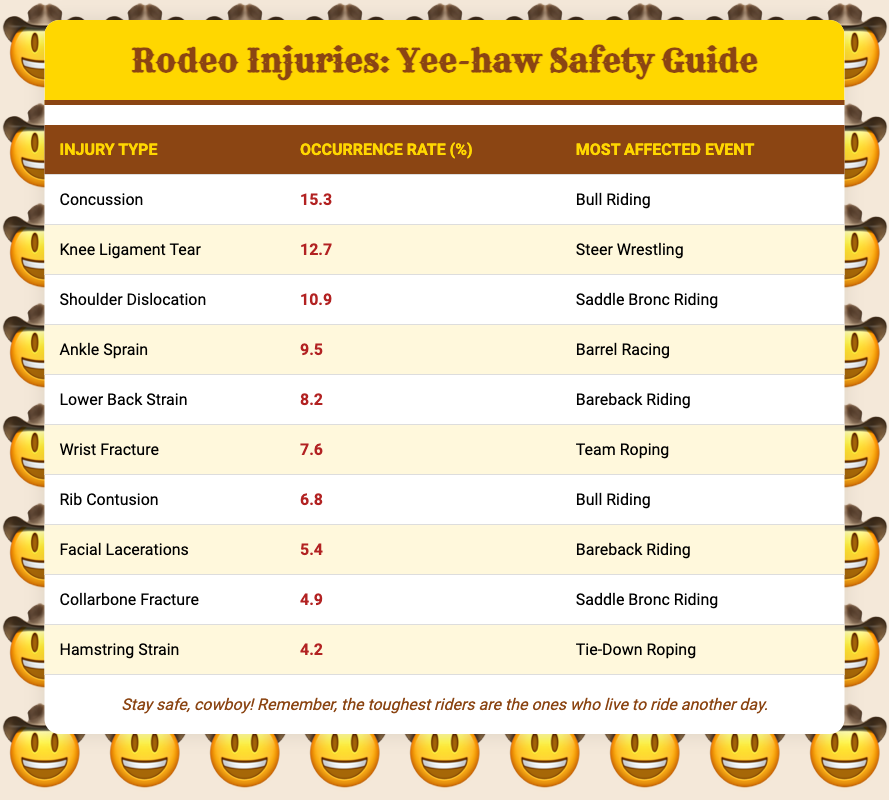What is the occurrence rate of concussions in rodeo? The occurrence rate of concussions can be found directly in the table under the "Occurrence Rate (%)" column corresponding to "Concussion" in the "Injury Type" column, which states 15.3%.
Answer: 15.3% Which injury has the highest occurrence rate? The highest occurrence rate is found by comparing all the rates listed in the "Occurrence Rate (%)" column. Concussions have the highest rate at 15.3%.
Answer: Concussion Is the occurrence rate of facial lacerations higher than that of wrist fractures? To determine this, we can compare the occurrence rates listed in the table. Facial lacerations have a rate of 5.4%, and wrist fractures have a rate of 7.6%. Since 5.4% is less than 7.6%, the occurrence rate of facial lacerations is not higher.
Answer: No What is the average occurrence rate of all injuries listed? To find the average, we sum all the occurrence rates: 15.3 + 12.7 + 10.9 + 9.5 + 8.2 + 7.6 + 6.8 + 5.4 + 4.9 + 4.2 = 79.5%. There are 10 injuries, so we divide 79.5 by 10, which gives us an average of 7.95%.
Answer: 7.95% Which injury type occurs most frequently in bull riding? Looking at the "Most Affected Event" column, we find that both "Concussion" and "Rib Contusion" are associated with "Bull Riding." Among these, the one with the higher occurrence rate is concussion at 15.3%.
Answer: Concussion 